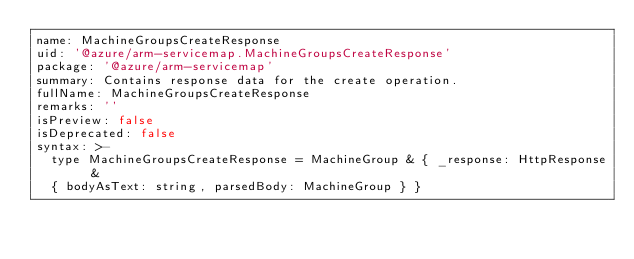<code> <loc_0><loc_0><loc_500><loc_500><_YAML_>name: MachineGroupsCreateResponse
uid: '@azure/arm-servicemap.MachineGroupsCreateResponse'
package: '@azure/arm-servicemap'
summary: Contains response data for the create operation.
fullName: MachineGroupsCreateResponse
remarks: ''
isPreview: false
isDeprecated: false
syntax: >-
  type MachineGroupsCreateResponse = MachineGroup & { _response: HttpResponse &
  { bodyAsText: string, parsedBody: MachineGroup } }
</code> 